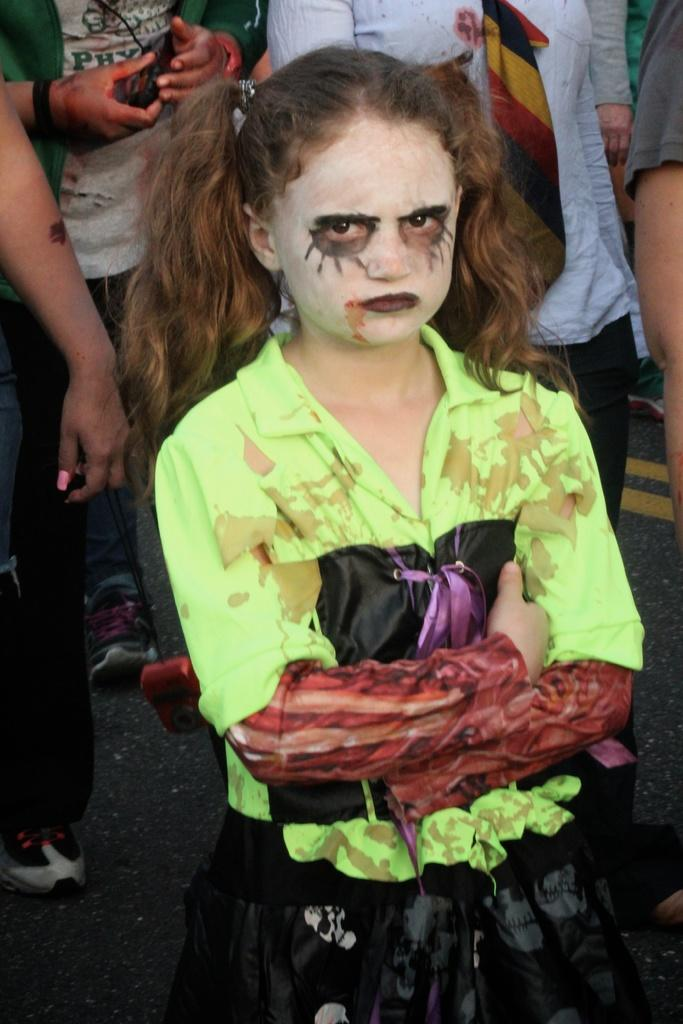How many people are in the image? There are people standing in the image. Can you describe the clothing of one of the people? One person is wearing a neon-colored dress. What additional feature can be seen on the person in the neon-colored dress? The person in the neon-colored dress has face paint on their face. What type of learning material is being used by the person in the neon-colored dress? There is no learning material visible in the image, and the person in the neon-colored dress is not engaged in any learning activity. 